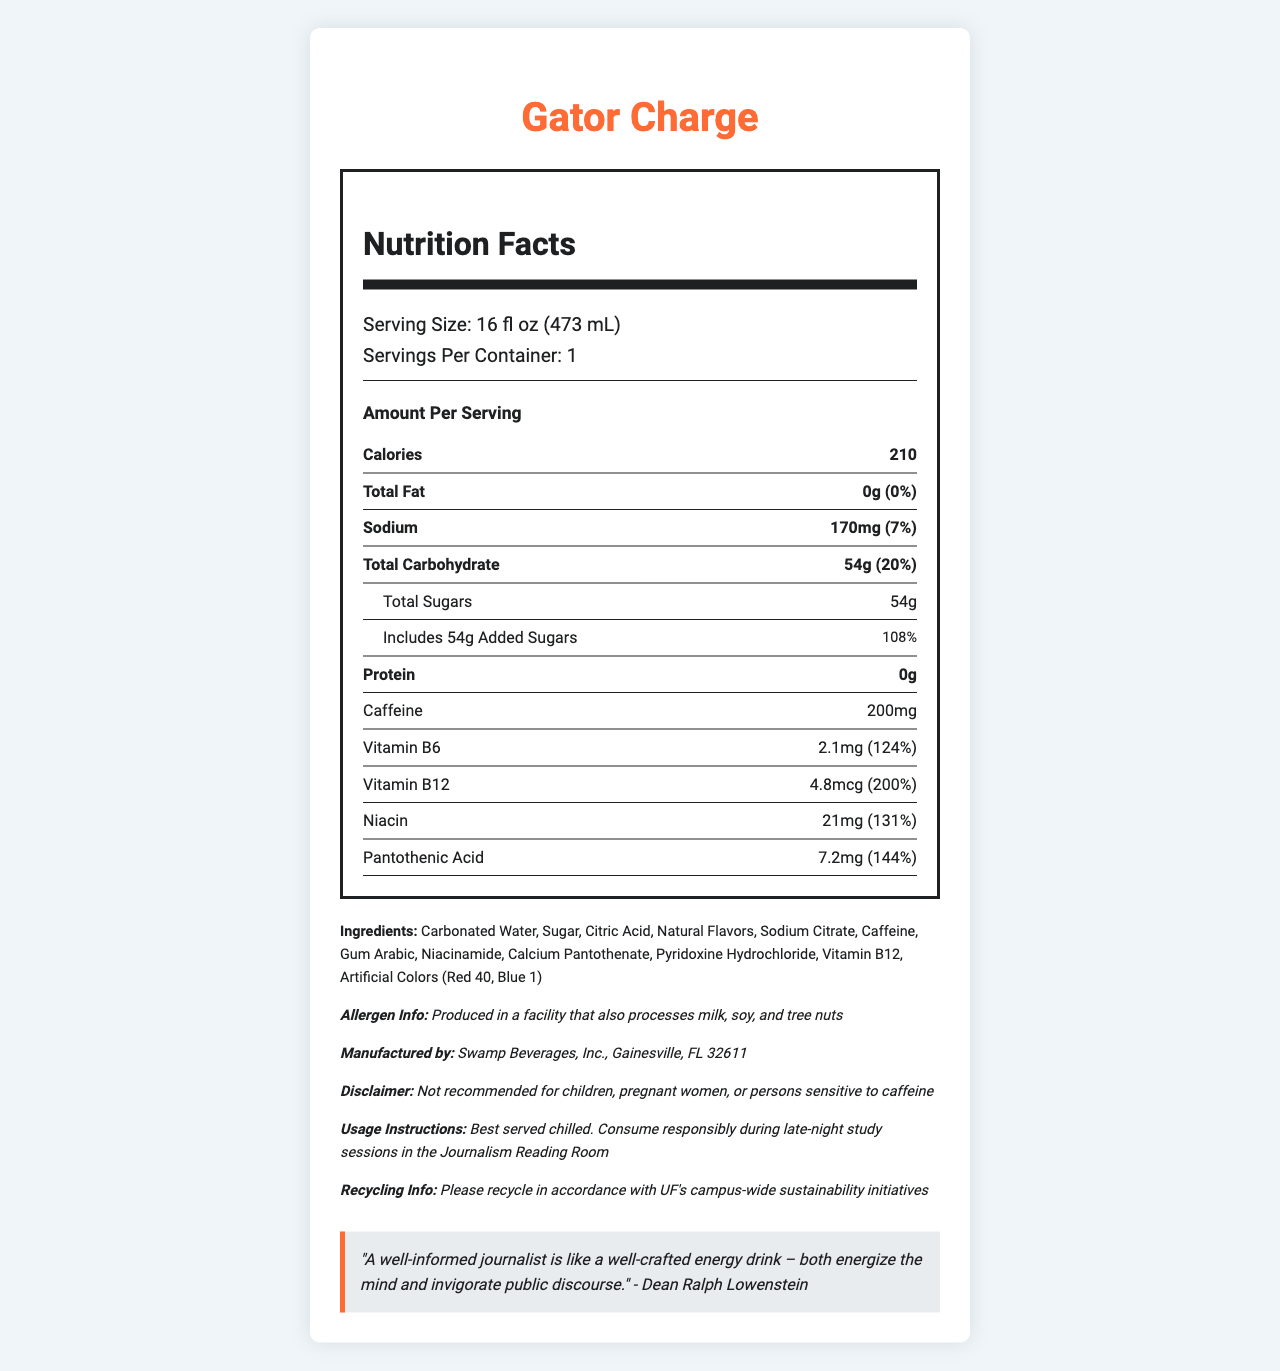what is the serving size for Gator Charge? The serving size is clearly stated under the "Serving Size" section as 16 fl oz (473 mL).
Answer: 16 fl oz (473 mL) how many servings are in a Gator Charge container? The document specifies that there is 1 serving per container under the "Servings Per Container" section.
Answer: 1 what is the calorie count per serving of Gator Charge? The calorie count per serving is listed as 210 calories in the "Amount Per Serving" section.
Answer: 210 how much sodium does Gator Charge contain per serving? The amount of sodium per serving is given as 170mg in the "Sodium" section.
Answer: 170mg what percentage of the daily value of total carbohydrate is in one serving of Gator Charge? The document states that the daily value percentage for total carbohydrate per serving is 20%.
Answer: 20% what are the main ingredients in Gator Charge? A. Sugar, Citric Acid, Caffeine B. Sugar, Vitamin C, Aspartame C. Natural Flavors, Sucralose, Red 40 The ingredients section lists "Sugar," "Citric Acid," and "Caffeine" as part of the main ingredients.
Answer: A. Sugar, Citric Acid, Caffeine which vitamin in Gator Charge has the highest daily value percentage? 1. Vitamin B6 2. Vitamin B12 3. Niacin Vitamin B12 has a daily value percentage of 200%, which is the highest among the listed vitamins.
Answer: 2. Vitamin B12 is Gator Charge safe for children or pregnant women? The disclaimer section clearly states that it is "Not recommended for children, pregnant women, or persons sensitive to caffeine."
Answer: No summarize the main nutritional information of Gator Charge The summary provides an overview of the main nutritional components, along with key vitamins and ingredients mentioned in the document.
Answer: Gator Charge is an energy drink with a serving size of 16 fl oz (473 mL) and contains 210 calories per serving. It has 0g of total fat, 170mg of sodium (7% DV), 54g of total carbohydrates (20% DV) including 54g of sugars, and 0g of protein. Key vitamins include 124% DV of Vitamin B6, 200% DV of Vitamin B12, 131% DV of Niacin, and 144% DV of Pantothenic Acid. The product contains caffeine and various ingredients like sugar, citric acid, and natural flavors. what quantity of caffeine is in Gator Charge? The document lists the caffeine content as 200mg.
Answer: 200mg does Gator Charge contain any fat? The label states that the total fat content is 0g, which means it contains no fat.
Answer: No what does Dean Ralph Lowenstein compare a well-informed journalist to? Dean Ralph Lowenstein's quote in the document compares a well-informed journalist to a well-crafted energy drink, both energizing the mind and invigorating public discourse.
Answer: A well-crafted energy drink how many grams of added sugars are in one serving of Gator Charge? The document specifies that there are 54g of added sugars in one serving of the drink.
Answer: 54g which artificial colors are included in the ingredients of Gator Charge? The ingredients section lists the artificial colors as Red 40 and Blue 1.
Answer: Red 40, Blue 1 where is Gator Charge manufactured? The document states that Gator Charge is manufactured by Swamp Beverages, Inc. in Gainesville, FL 32611.
Answer: Gainesville, FL 32611 what is the purpose of sodium citrate in Gator Charge? The document lists sodium citrate as an ingredient but does not provide specific information on its purpose or role in the drink.
Answer: Not enough information 